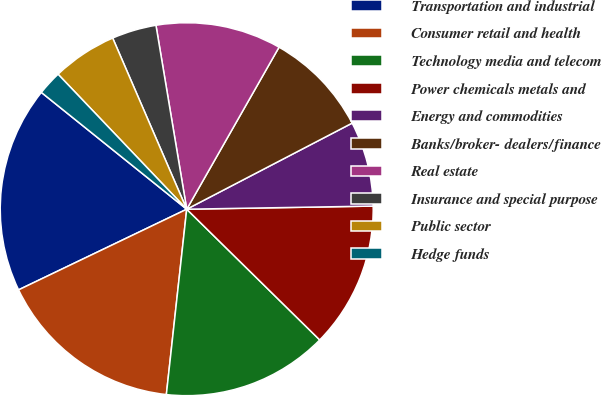Convert chart. <chart><loc_0><loc_0><loc_500><loc_500><pie_chart><fcel>Transportation and industrial<fcel>Consumer retail and health<fcel>Technology media and telecom<fcel>Power chemicals metals and<fcel>Energy and commodities<fcel>Banks/broker- dealers/finance<fcel>Real estate<fcel>Insurance and special purpose<fcel>Public sector<fcel>Hedge funds<nl><fcel>17.89%<fcel>16.14%<fcel>14.38%<fcel>12.63%<fcel>7.37%<fcel>9.12%<fcel>10.88%<fcel>3.86%<fcel>5.62%<fcel>2.11%<nl></chart> 